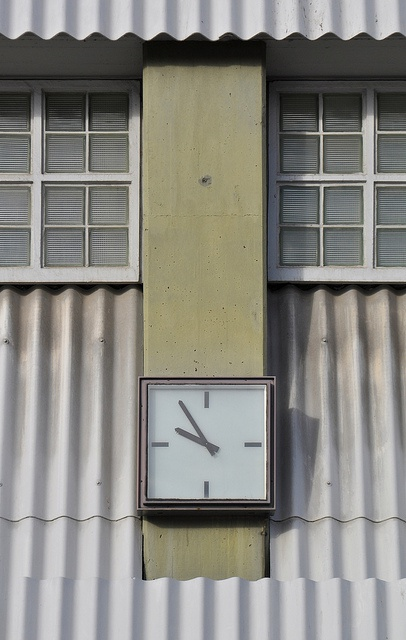Describe the objects in this image and their specific colors. I can see a clock in darkgray, lightgray, and black tones in this image. 